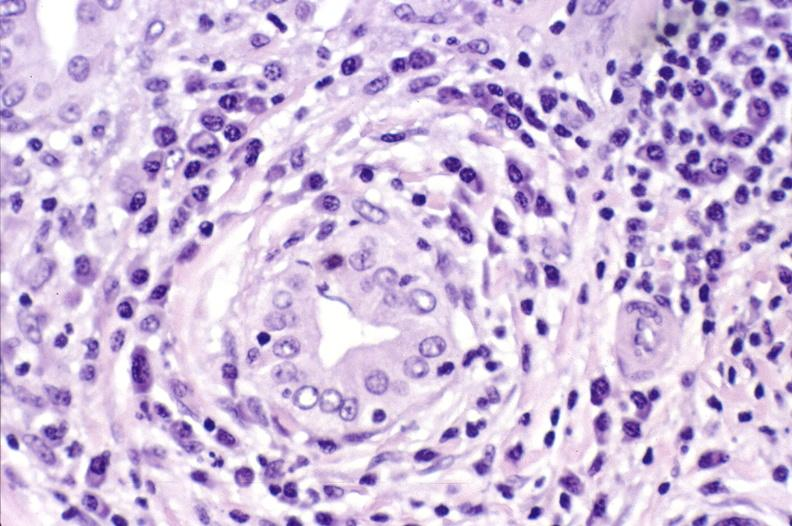s liver present?
Answer the question using a single word or phrase. Yes 